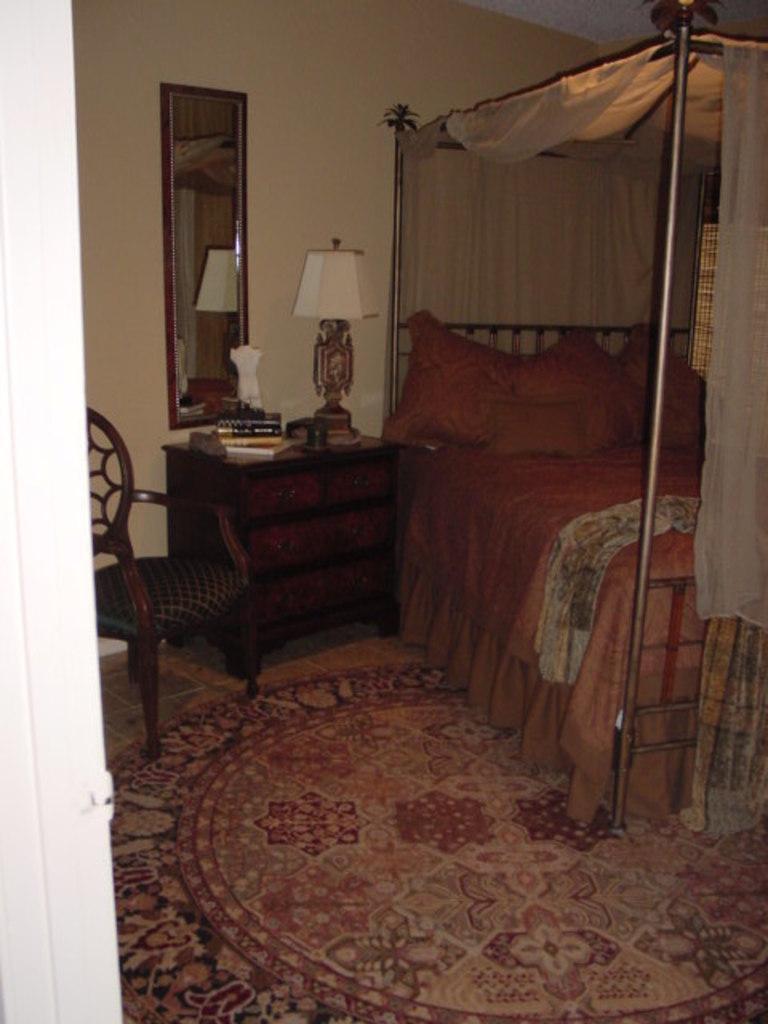In one or two sentences, can you explain what this image depicts? In this picture we can see a chair, mirror, lamp and a bed. 